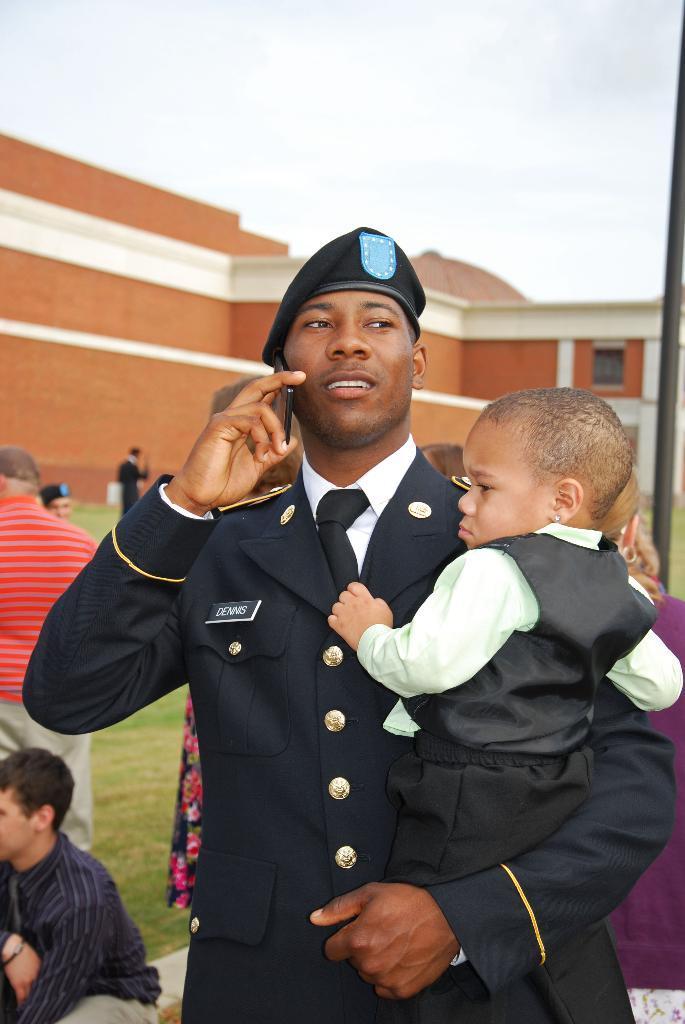Describe this image in one or two sentences. In this image in the front there is a person standing and holding a kid in his arms and speaking on the phone. In the center there are persons sitting and standing and there is grass on the ground. In the background there is a building and the sky is cloudy. 